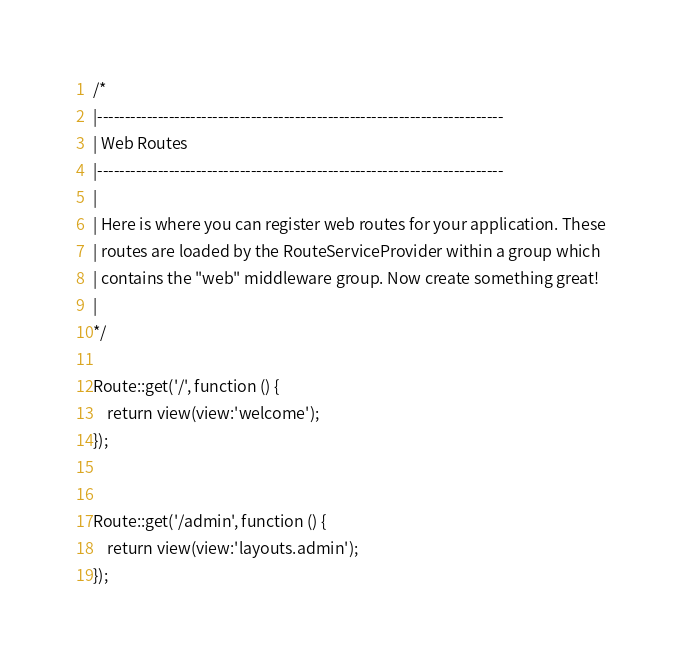Convert code to text. <code><loc_0><loc_0><loc_500><loc_500><_PHP_>/*
|--------------------------------------------------------------------------
| Web Routes
|--------------------------------------------------------------------------
|
| Here is where you can register web routes for your application. These
| routes are loaded by the RouteServiceProvider within a group which
| contains the "web" middleware group. Now create something great!
|
*/

Route::get('/', function () {
    return view(view:'welcome');
});


Route::get('/admin', function () {
    return view(view:'layouts.admin');
});


</code> 